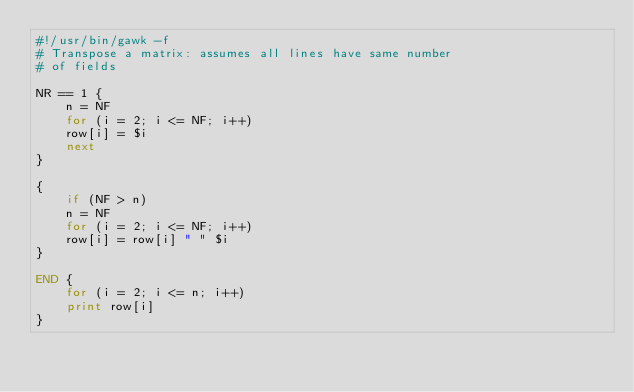Convert code to text. <code><loc_0><loc_0><loc_500><loc_500><_Awk_>#!/usr/bin/gawk -f
# Transpose a matrix: assumes all lines have same number
# of fields

NR == 1 {
    n = NF
    for (i = 2; i <= NF; i++)
	row[i] = $i
    next
}

{
    if (NF > n)
	n = NF
    for (i = 2; i <= NF; i++)
	row[i] = row[i] " " $i
}

END {
    for (i = 2; i <= n; i++)
	print row[i]
}

</code> 